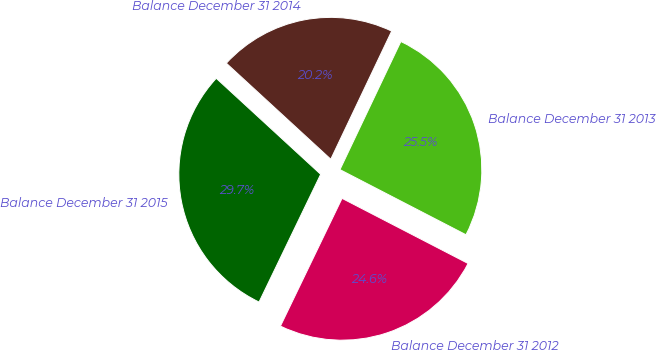<chart> <loc_0><loc_0><loc_500><loc_500><pie_chart><fcel>Balance December 31 2012<fcel>Balance December 31 2013<fcel>Balance December 31 2014<fcel>Balance December 31 2015<nl><fcel>24.56%<fcel>25.53%<fcel>20.23%<fcel>29.68%<nl></chart> 